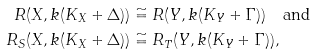<formula> <loc_0><loc_0><loc_500><loc_500>R ( X , k ( K _ { X } + \Delta ) ) & \cong R ( Y , k ( K _ { Y } + \Gamma ) ) \quad \text {and} \\ R _ { S } ( X , k ( K _ { X } + \Delta ) ) & \cong R _ { T } ( Y , k ( K _ { Y } + \Gamma ) ) ,</formula> 